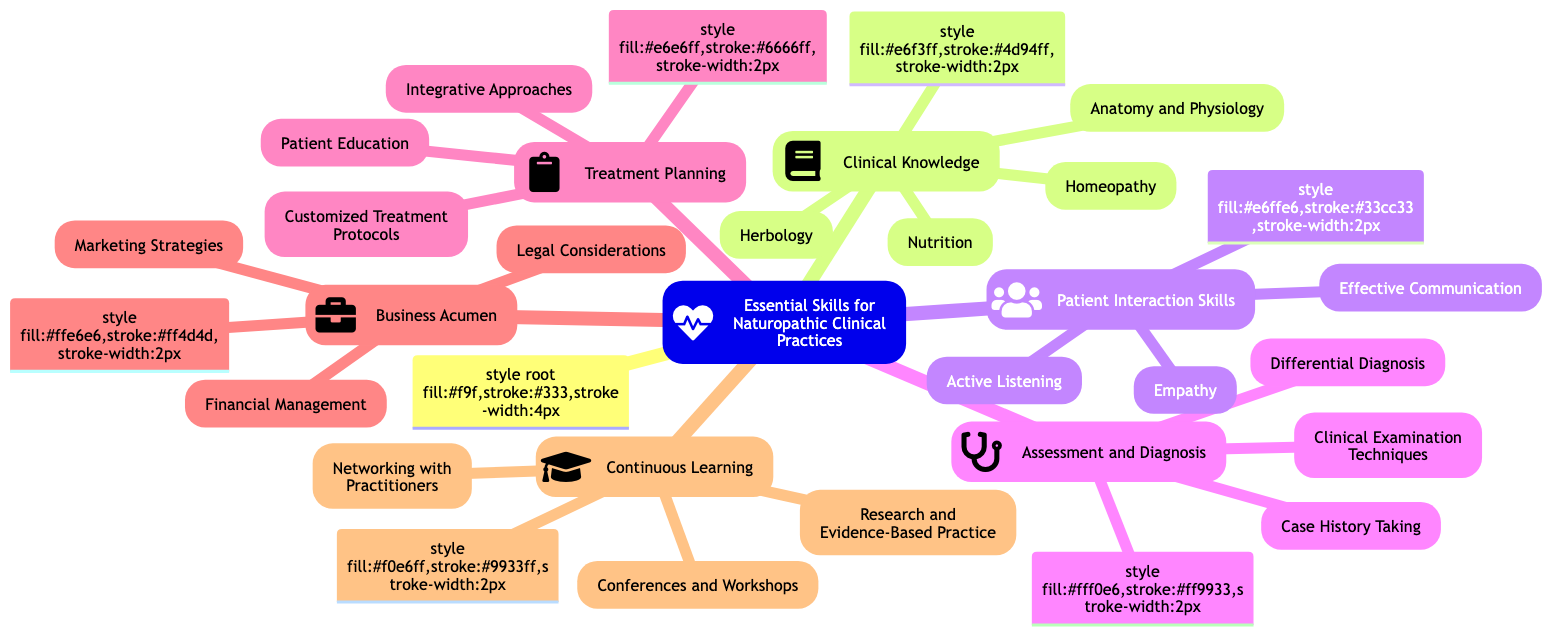what are the main categories in the mind map? The mind map outlines six main categories which are Clinical Knowledge, Patient Interaction Skills, Assessment and Diagnosis, Treatment Planning, Business Acumen, and Continuous Learning.
Answer: Clinical Knowledge, Patient Interaction Skills, Assessment and Diagnosis, Treatment Planning, Business Acumen, Continuous Learning how many skills are listed under Patient Interaction Skills? In the Patient Interaction Skills category, there are three listed skills: Active Listening, Empathy, and Effective Communication.
Answer: 3 what icons are used for the Clinical Knowledge category? The icon used for the Clinical Knowledge category is a book symbol (fa fa-book), which represents the educational aspect of this skill set.
Answer: fa fa-book which category includes Customized Treatment Protocols? The skill Customized Treatment Protocols is included in the Treatment Planning category, indicating its relevance to developing individual care plans for patients.
Answer: Treatment Planning what are the skills related to Continuous Learning? The Continuous Learning category includes three skills: Conferences and Workshops, Research and Evidence-Based Practice, and Networking with Practitioners, focusing on professional development and collaboration.
Answer: Conferences and Workshops, Research and Evidence-Based Practice, Networking with Practitioners which skills fall under Business Acumen and how many are there? The Business Acumen category consists of three skills: Marketing Strategies, Financial Management, and Legal Considerations, highlighting the importance of business knowledge in running a clinical practice.
Answer: Marketing Strategies, Financial Management, Legal Considerations which two categories focus on the patient's experience? The two categories focusing on the patient's experience are Patient Interaction Skills, which emphasizes communication and rapport, and Treatment Planning, which focuses on developing tailored health strategies.
Answer: Patient Interaction Skills, Treatment Planning how many skills are under the Assessment and Diagnosis category? The Assessment and Diagnosis category includes three skills: Clinical Examination Techniques, Differential Diagnosis, and Case History Taking, which are essential for effective patient evaluations.
Answer: 3 